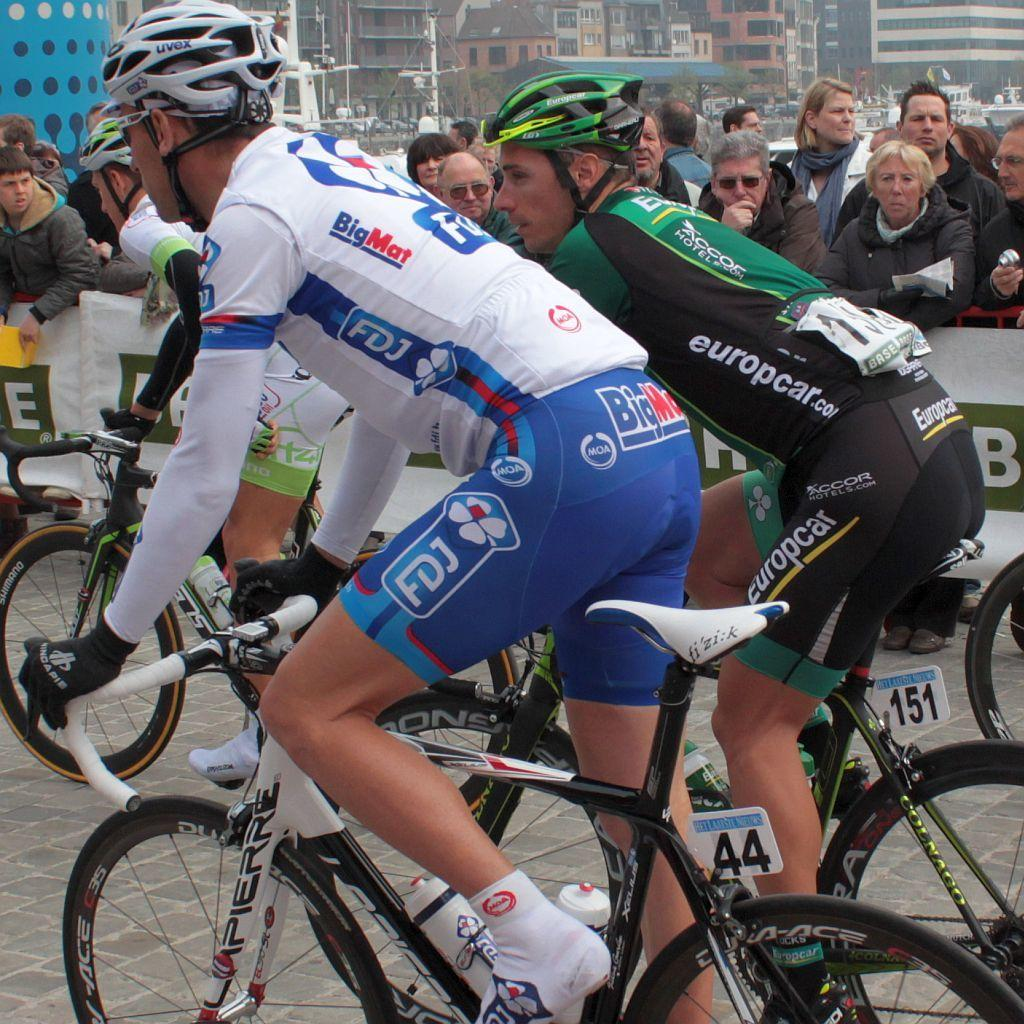What can be seen in the background of the image? There are buildings in the background of the image. What are the people in the image doing? The people in the image are riding bicycles. What safety precaution are the people taking while riding bicycles? The people riding bicycles are wearing helmets. Can you describe the presence of other individuals in the image? There is a crowd visible in the image. What hobbies do the ducks in the image enjoy? There are no ducks present in the image, so we cannot determine their hobbies. Can you tell me how the people in the image are talking to each other? The conversation does not mention any talking or communication between the people in the image. 